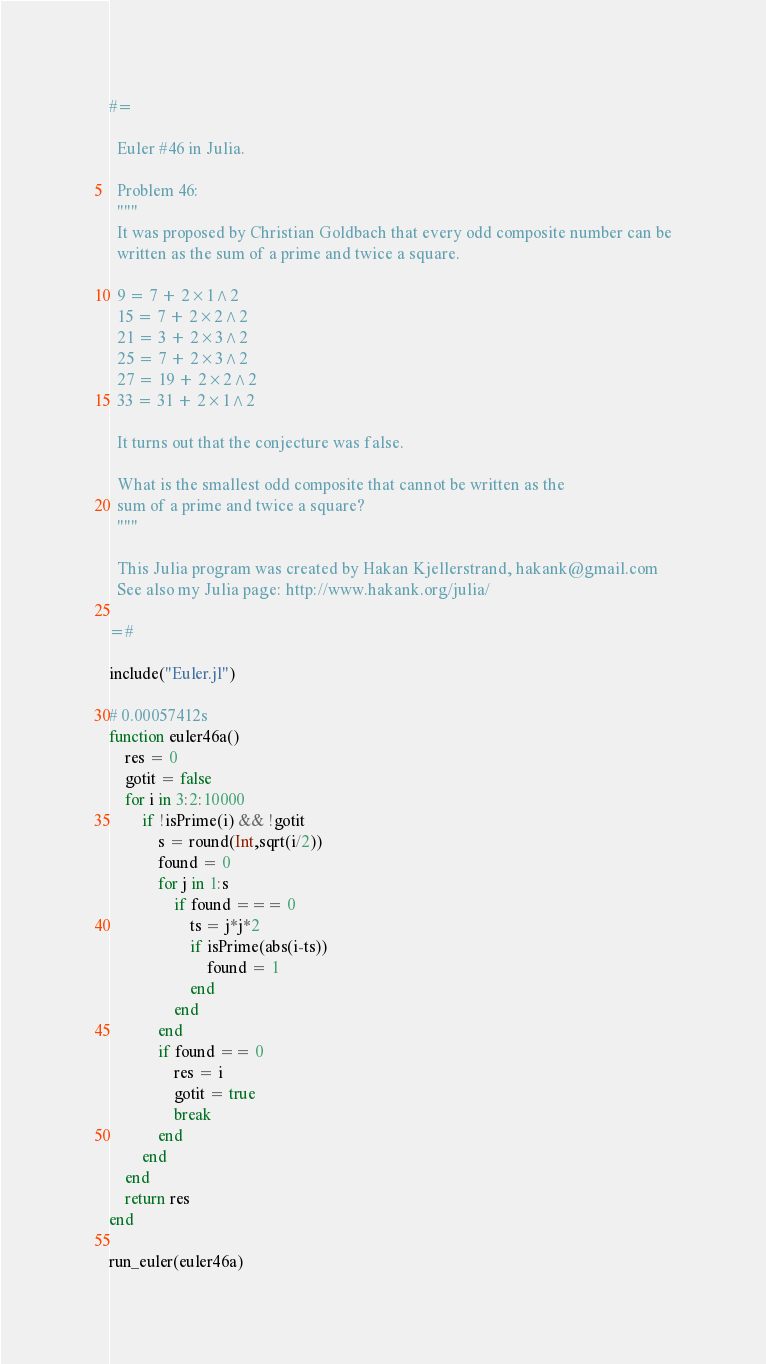<code> <loc_0><loc_0><loc_500><loc_500><_Julia_>#=

  Euler #46 in Julia.

  Problem 46:
  """
  It was proposed by Christian Goldbach that every odd composite number can be
  written as the sum of a prime and twice a square.

  9 = 7 + 2×1^2
  15 = 7 + 2×2^2
  21 = 3 + 2×3^2
  25 = 7 + 2×3^2
  27 = 19 + 2×2^2
  33 = 31 + 2×1^2

  It turns out that the conjecture was false.

  What is the smallest odd composite that cannot be written as the
  sum of a prime and twice a square?
  """

  This Julia program was created by Hakan Kjellerstrand, hakank@gmail.com
  See also my Julia page: http://www.hakank.org/julia/

=#

include("Euler.jl")

# 0.00057412s
function euler46a()
    res = 0
    gotit = false
    for i in 3:2:10000
        if !isPrime(i) && !gotit
            s = round(Int,sqrt(i/2))
            found = 0
            for j in 1:s
                if found === 0
                    ts = j*j*2
                    if isPrime(abs(i-ts))
                        found = 1
                    end
                end
            end
            if found == 0
                res = i
                gotit = true
                break
            end
        end
    end
    return res
end

run_euler(euler46a)
</code> 